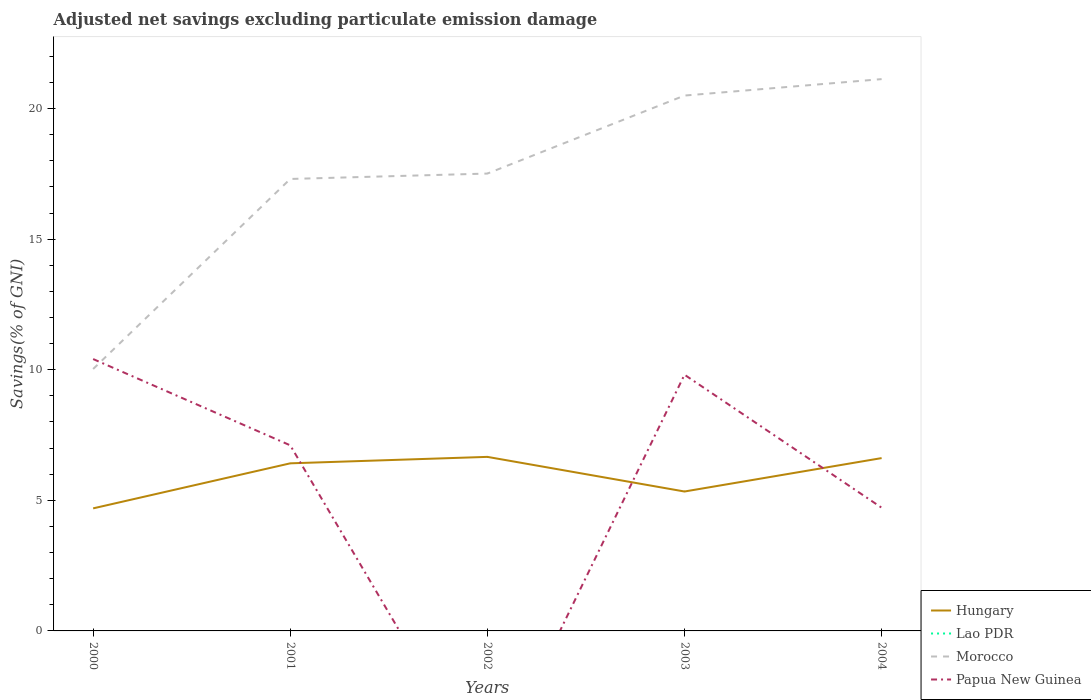Does the line corresponding to Morocco intersect with the line corresponding to Lao PDR?
Your response must be concise. No. Is the number of lines equal to the number of legend labels?
Your response must be concise. No. Across all years, what is the maximum adjusted net savings in Morocco?
Keep it short and to the point. 10.03. What is the total adjusted net savings in Hungary in the graph?
Ensure brevity in your answer.  1.08. What is the difference between the highest and the second highest adjusted net savings in Morocco?
Ensure brevity in your answer.  11.1. What is the difference between the highest and the lowest adjusted net savings in Lao PDR?
Keep it short and to the point. 0. Is the adjusted net savings in Papua New Guinea strictly greater than the adjusted net savings in Hungary over the years?
Your answer should be very brief. No. How many lines are there?
Your answer should be very brief. 3. How many years are there in the graph?
Ensure brevity in your answer.  5. What is the difference between two consecutive major ticks on the Y-axis?
Keep it short and to the point. 5. Are the values on the major ticks of Y-axis written in scientific E-notation?
Offer a terse response. No. Where does the legend appear in the graph?
Provide a short and direct response. Bottom right. How are the legend labels stacked?
Provide a succinct answer. Vertical. What is the title of the graph?
Provide a succinct answer. Adjusted net savings excluding particulate emission damage. What is the label or title of the Y-axis?
Your answer should be compact. Savings(% of GNI). What is the Savings(% of GNI) of Hungary in 2000?
Provide a succinct answer. 4.69. What is the Savings(% of GNI) in Morocco in 2000?
Your response must be concise. 10.03. What is the Savings(% of GNI) of Papua New Guinea in 2000?
Offer a terse response. 10.41. What is the Savings(% of GNI) of Hungary in 2001?
Offer a terse response. 6.42. What is the Savings(% of GNI) in Lao PDR in 2001?
Offer a terse response. 0. What is the Savings(% of GNI) in Morocco in 2001?
Offer a terse response. 17.31. What is the Savings(% of GNI) of Papua New Guinea in 2001?
Your response must be concise. 7.11. What is the Savings(% of GNI) of Hungary in 2002?
Offer a very short reply. 6.66. What is the Savings(% of GNI) in Lao PDR in 2002?
Provide a short and direct response. 0. What is the Savings(% of GNI) of Morocco in 2002?
Keep it short and to the point. 17.51. What is the Savings(% of GNI) of Papua New Guinea in 2002?
Your response must be concise. 0. What is the Savings(% of GNI) in Hungary in 2003?
Keep it short and to the point. 5.34. What is the Savings(% of GNI) in Lao PDR in 2003?
Provide a short and direct response. 0. What is the Savings(% of GNI) in Morocco in 2003?
Offer a terse response. 20.5. What is the Savings(% of GNI) of Papua New Guinea in 2003?
Provide a short and direct response. 9.81. What is the Savings(% of GNI) in Hungary in 2004?
Make the answer very short. 6.62. What is the Savings(% of GNI) in Morocco in 2004?
Ensure brevity in your answer.  21.13. What is the Savings(% of GNI) in Papua New Guinea in 2004?
Give a very brief answer. 4.72. Across all years, what is the maximum Savings(% of GNI) in Hungary?
Your response must be concise. 6.66. Across all years, what is the maximum Savings(% of GNI) in Morocco?
Provide a short and direct response. 21.13. Across all years, what is the maximum Savings(% of GNI) in Papua New Guinea?
Your answer should be compact. 10.41. Across all years, what is the minimum Savings(% of GNI) in Hungary?
Your answer should be very brief. 4.69. Across all years, what is the minimum Savings(% of GNI) in Morocco?
Provide a succinct answer. 10.03. What is the total Savings(% of GNI) in Hungary in the graph?
Make the answer very short. 29.73. What is the total Savings(% of GNI) of Morocco in the graph?
Offer a terse response. 86.47. What is the total Savings(% of GNI) in Papua New Guinea in the graph?
Keep it short and to the point. 32.04. What is the difference between the Savings(% of GNI) of Hungary in 2000 and that in 2001?
Ensure brevity in your answer.  -1.72. What is the difference between the Savings(% of GNI) of Morocco in 2000 and that in 2001?
Ensure brevity in your answer.  -7.28. What is the difference between the Savings(% of GNI) in Papua New Guinea in 2000 and that in 2001?
Offer a terse response. 3.3. What is the difference between the Savings(% of GNI) in Hungary in 2000 and that in 2002?
Make the answer very short. -1.97. What is the difference between the Savings(% of GNI) of Morocco in 2000 and that in 2002?
Provide a succinct answer. -7.48. What is the difference between the Savings(% of GNI) in Hungary in 2000 and that in 2003?
Keep it short and to the point. -0.65. What is the difference between the Savings(% of GNI) of Morocco in 2000 and that in 2003?
Your answer should be very brief. -10.47. What is the difference between the Savings(% of GNI) of Papua New Guinea in 2000 and that in 2003?
Provide a short and direct response. 0.6. What is the difference between the Savings(% of GNI) of Hungary in 2000 and that in 2004?
Provide a short and direct response. -1.92. What is the difference between the Savings(% of GNI) of Morocco in 2000 and that in 2004?
Make the answer very short. -11.1. What is the difference between the Savings(% of GNI) of Papua New Guinea in 2000 and that in 2004?
Offer a terse response. 5.69. What is the difference between the Savings(% of GNI) of Hungary in 2001 and that in 2002?
Make the answer very short. -0.25. What is the difference between the Savings(% of GNI) in Morocco in 2001 and that in 2002?
Your answer should be very brief. -0.21. What is the difference between the Savings(% of GNI) of Hungary in 2001 and that in 2003?
Provide a succinct answer. 1.08. What is the difference between the Savings(% of GNI) in Morocco in 2001 and that in 2003?
Keep it short and to the point. -3.19. What is the difference between the Savings(% of GNI) in Papua New Guinea in 2001 and that in 2003?
Your answer should be compact. -2.7. What is the difference between the Savings(% of GNI) of Hungary in 2001 and that in 2004?
Give a very brief answer. -0.2. What is the difference between the Savings(% of GNI) of Morocco in 2001 and that in 2004?
Give a very brief answer. -3.82. What is the difference between the Savings(% of GNI) in Papua New Guinea in 2001 and that in 2004?
Provide a short and direct response. 2.39. What is the difference between the Savings(% of GNI) of Hungary in 2002 and that in 2003?
Your response must be concise. 1.33. What is the difference between the Savings(% of GNI) of Morocco in 2002 and that in 2003?
Your response must be concise. -2.99. What is the difference between the Savings(% of GNI) of Hungary in 2002 and that in 2004?
Keep it short and to the point. 0.05. What is the difference between the Savings(% of GNI) of Morocco in 2002 and that in 2004?
Your response must be concise. -3.62. What is the difference between the Savings(% of GNI) of Hungary in 2003 and that in 2004?
Keep it short and to the point. -1.28. What is the difference between the Savings(% of GNI) of Morocco in 2003 and that in 2004?
Provide a succinct answer. -0.63. What is the difference between the Savings(% of GNI) in Papua New Guinea in 2003 and that in 2004?
Keep it short and to the point. 5.09. What is the difference between the Savings(% of GNI) in Hungary in 2000 and the Savings(% of GNI) in Morocco in 2001?
Offer a terse response. -12.61. What is the difference between the Savings(% of GNI) of Hungary in 2000 and the Savings(% of GNI) of Papua New Guinea in 2001?
Keep it short and to the point. -2.41. What is the difference between the Savings(% of GNI) in Morocco in 2000 and the Savings(% of GNI) in Papua New Guinea in 2001?
Your answer should be compact. 2.92. What is the difference between the Savings(% of GNI) in Hungary in 2000 and the Savings(% of GNI) in Morocco in 2002?
Offer a terse response. -12.82. What is the difference between the Savings(% of GNI) of Hungary in 2000 and the Savings(% of GNI) of Morocco in 2003?
Your response must be concise. -15.81. What is the difference between the Savings(% of GNI) in Hungary in 2000 and the Savings(% of GNI) in Papua New Guinea in 2003?
Ensure brevity in your answer.  -5.12. What is the difference between the Savings(% of GNI) in Morocco in 2000 and the Savings(% of GNI) in Papua New Guinea in 2003?
Provide a short and direct response. 0.22. What is the difference between the Savings(% of GNI) of Hungary in 2000 and the Savings(% of GNI) of Morocco in 2004?
Offer a terse response. -16.44. What is the difference between the Savings(% of GNI) of Hungary in 2000 and the Savings(% of GNI) of Papua New Guinea in 2004?
Your answer should be compact. -0.03. What is the difference between the Savings(% of GNI) of Morocco in 2000 and the Savings(% of GNI) of Papua New Guinea in 2004?
Offer a terse response. 5.31. What is the difference between the Savings(% of GNI) of Hungary in 2001 and the Savings(% of GNI) of Morocco in 2002?
Your answer should be compact. -11.09. What is the difference between the Savings(% of GNI) in Hungary in 2001 and the Savings(% of GNI) in Morocco in 2003?
Your answer should be very brief. -14.08. What is the difference between the Savings(% of GNI) of Hungary in 2001 and the Savings(% of GNI) of Papua New Guinea in 2003?
Your answer should be compact. -3.39. What is the difference between the Savings(% of GNI) of Morocco in 2001 and the Savings(% of GNI) of Papua New Guinea in 2003?
Your answer should be compact. 7.5. What is the difference between the Savings(% of GNI) of Hungary in 2001 and the Savings(% of GNI) of Morocco in 2004?
Give a very brief answer. -14.71. What is the difference between the Savings(% of GNI) of Hungary in 2001 and the Savings(% of GNI) of Papua New Guinea in 2004?
Provide a short and direct response. 1.7. What is the difference between the Savings(% of GNI) in Morocco in 2001 and the Savings(% of GNI) in Papua New Guinea in 2004?
Your answer should be very brief. 12.59. What is the difference between the Savings(% of GNI) in Hungary in 2002 and the Savings(% of GNI) in Morocco in 2003?
Keep it short and to the point. -13.83. What is the difference between the Savings(% of GNI) of Hungary in 2002 and the Savings(% of GNI) of Papua New Guinea in 2003?
Make the answer very short. -3.15. What is the difference between the Savings(% of GNI) of Morocco in 2002 and the Savings(% of GNI) of Papua New Guinea in 2003?
Your response must be concise. 7.7. What is the difference between the Savings(% of GNI) of Hungary in 2002 and the Savings(% of GNI) of Morocco in 2004?
Provide a short and direct response. -14.46. What is the difference between the Savings(% of GNI) in Hungary in 2002 and the Savings(% of GNI) in Papua New Guinea in 2004?
Offer a terse response. 1.95. What is the difference between the Savings(% of GNI) in Morocco in 2002 and the Savings(% of GNI) in Papua New Guinea in 2004?
Your answer should be very brief. 12.79. What is the difference between the Savings(% of GNI) of Hungary in 2003 and the Savings(% of GNI) of Morocco in 2004?
Provide a succinct answer. -15.79. What is the difference between the Savings(% of GNI) in Hungary in 2003 and the Savings(% of GNI) in Papua New Guinea in 2004?
Offer a terse response. 0.62. What is the difference between the Savings(% of GNI) in Morocco in 2003 and the Savings(% of GNI) in Papua New Guinea in 2004?
Ensure brevity in your answer.  15.78. What is the average Savings(% of GNI) in Hungary per year?
Give a very brief answer. 5.95. What is the average Savings(% of GNI) in Lao PDR per year?
Keep it short and to the point. 0. What is the average Savings(% of GNI) in Morocco per year?
Your response must be concise. 17.29. What is the average Savings(% of GNI) of Papua New Guinea per year?
Ensure brevity in your answer.  6.41. In the year 2000, what is the difference between the Savings(% of GNI) in Hungary and Savings(% of GNI) in Morocco?
Ensure brevity in your answer.  -5.34. In the year 2000, what is the difference between the Savings(% of GNI) in Hungary and Savings(% of GNI) in Papua New Guinea?
Your answer should be very brief. -5.72. In the year 2000, what is the difference between the Savings(% of GNI) of Morocco and Savings(% of GNI) of Papua New Guinea?
Offer a very short reply. -0.38. In the year 2001, what is the difference between the Savings(% of GNI) of Hungary and Savings(% of GNI) of Morocco?
Offer a very short reply. -10.89. In the year 2001, what is the difference between the Savings(% of GNI) of Hungary and Savings(% of GNI) of Papua New Guinea?
Provide a short and direct response. -0.69. In the year 2001, what is the difference between the Savings(% of GNI) in Morocco and Savings(% of GNI) in Papua New Guinea?
Make the answer very short. 10.2. In the year 2002, what is the difference between the Savings(% of GNI) in Hungary and Savings(% of GNI) in Morocco?
Your answer should be compact. -10.85. In the year 2003, what is the difference between the Savings(% of GNI) in Hungary and Savings(% of GNI) in Morocco?
Provide a short and direct response. -15.16. In the year 2003, what is the difference between the Savings(% of GNI) in Hungary and Savings(% of GNI) in Papua New Guinea?
Make the answer very short. -4.47. In the year 2003, what is the difference between the Savings(% of GNI) of Morocco and Savings(% of GNI) of Papua New Guinea?
Ensure brevity in your answer.  10.69. In the year 2004, what is the difference between the Savings(% of GNI) in Hungary and Savings(% of GNI) in Morocco?
Provide a succinct answer. -14.51. In the year 2004, what is the difference between the Savings(% of GNI) of Hungary and Savings(% of GNI) of Papua New Guinea?
Ensure brevity in your answer.  1.9. In the year 2004, what is the difference between the Savings(% of GNI) in Morocco and Savings(% of GNI) in Papua New Guinea?
Ensure brevity in your answer.  16.41. What is the ratio of the Savings(% of GNI) of Hungary in 2000 to that in 2001?
Offer a very short reply. 0.73. What is the ratio of the Savings(% of GNI) of Morocco in 2000 to that in 2001?
Your answer should be compact. 0.58. What is the ratio of the Savings(% of GNI) in Papua New Guinea in 2000 to that in 2001?
Your answer should be very brief. 1.46. What is the ratio of the Savings(% of GNI) in Hungary in 2000 to that in 2002?
Offer a terse response. 0.7. What is the ratio of the Savings(% of GNI) in Morocco in 2000 to that in 2002?
Give a very brief answer. 0.57. What is the ratio of the Savings(% of GNI) in Hungary in 2000 to that in 2003?
Provide a succinct answer. 0.88. What is the ratio of the Savings(% of GNI) of Morocco in 2000 to that in 2003?
Offer a terse response. 0.49. What is the ratio of the Savings(% of GNI) of Papua New Guinea in 2000 to that in 2003?
Offer a terse response. 1.06. What is the ratio of the Savings(% of GNI) in Hungary in 2000 to that in 2004?
Your response must be concise. 0.71. What is the ratio of the Savings(% of GNI) of Morocco in 2000 to that in 2004?
Ensure brevity in your answer.  0.47. What is the ratio of the Savings(% of GNI) of Papua New Guinea in 2000 to that in 2004?
Your answer should be very brief. 2.21. What is the ratio of the Savings(% of GNI) of Hungary in 2001 to that in 2002?
Make the answer very short. 0.96. What is the ratio of the Savings(% of GNI) in Hungary in 2001 to that in 2003?
Your answer should be very brief. 1.2. What is the ratio of the Savings(% of GNI) of Morocco in 2001 to that in 2003?
Provide a succinct answer. 0.84. What is the ratio of the Savings(% of GNI) of Papua New Guinea in 2001 to that in 2003?
Offer a very short reply. 0.72. What is the ratio of the Savings(% of GNI) in Hungary in 2001 to that in 2004?
Provide a succinct answer. 0.97. What is the ratio of the Savings(% of GNI) of Morocco in 2001 to that in 2004?
Your response must be concise. 0.82. What is the ratio of the Savings(% of GNI) in Papua New Guinea in 2001 to that in 2004?
Give a very brief answer. 1.51. What is the ratio of the Savings(% of GNI) in Hungary in 2002 to that in 2003?
Keep it short and to the point. 1.25. What is the ratio of the Savings(% of GNI) of Morocco in 2002 to that in 2003?
Your answer should be very brief. 0.85. What is the ratio of the Savings(% of GNI) in Hungary in 2002 to that in 2004?
Give a very brief answer. 1.01. What is the ratio of the Savings(% of GNI) of Morocco in 2002 to that in 2004?
Provide a short and direct response. 0.83. What is the ratio of the Savings(% of GNI) of Hungary in 2003 to that in 2004?
Offer a terse response. 0.81. What is the ratio of the Savings(% of GNI) in Morocco in 2003 to that in 2004?
Provide a short and direct response. 0.97. What is the ratio of the Savings(% of GNI) in Papua New Guinea in 2003 to that in 2004?
Provide a short and direct response. 2.08. What is the difference between the highest and the second highest Savings(% of GNI) in Hungary?
Offer a very short reply. 0.05. What is the difference between the highest and the second highest Savings(% of GNI) in Morocco?
Make the answer very short. 0.63. What is the difference between the highest and the second highest Savings(% of GNI) of Papua New Guinea?
Ensure brevity in your answer.  0.6. What is the difference between the highest and the lowest Savings(% of GNI) in Hungary?
Offer a terse response. 1.97. What is the difference between the highest and the lowest Savings(% of GNI) of Morocco?
Your response must be concise. 11.1. What is the difference between the highest and the lowest Savings(% of GNI) in Papua New Guinea?
Ensure brevity in your answer.  10.41. 